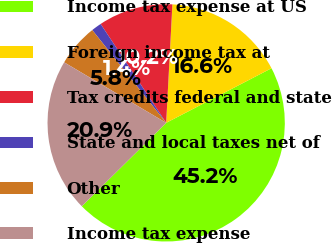Convert chart to OTSL. <chart><loc_0><loc_0><loc_500><loc_500><pie_chart><fcel>Income tax expense at US<fcel>Foreign income tax at<fcel>Tax credits federal and state<fcel>State and local taxes net of<fcel>Other<fcel>Income tax expense<nl><fcel>45.2%<fcel>16.55%<fcel>10.15%<fcel>1.39%<fcel>5.77%<fcel>20.93%<nl></chart> 